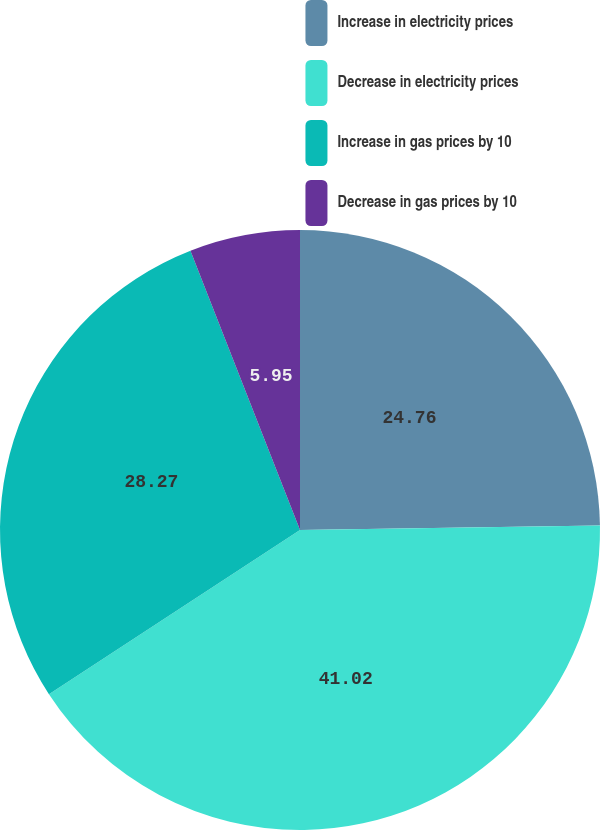Convert chart to OTSL. <chart><loc_0><loc_0><loc_500><loc_500><pie_chart><fcel>Increase in electricity prices<fcel>Decrease in electricity prices<fcel>Increase in gas prices by 10<fcel>Decrease in gas prices by 10<nl><fcel>24.76%<fcel>41.02%<fcel>28.27%<fcel>5.95%<nl></chart> 